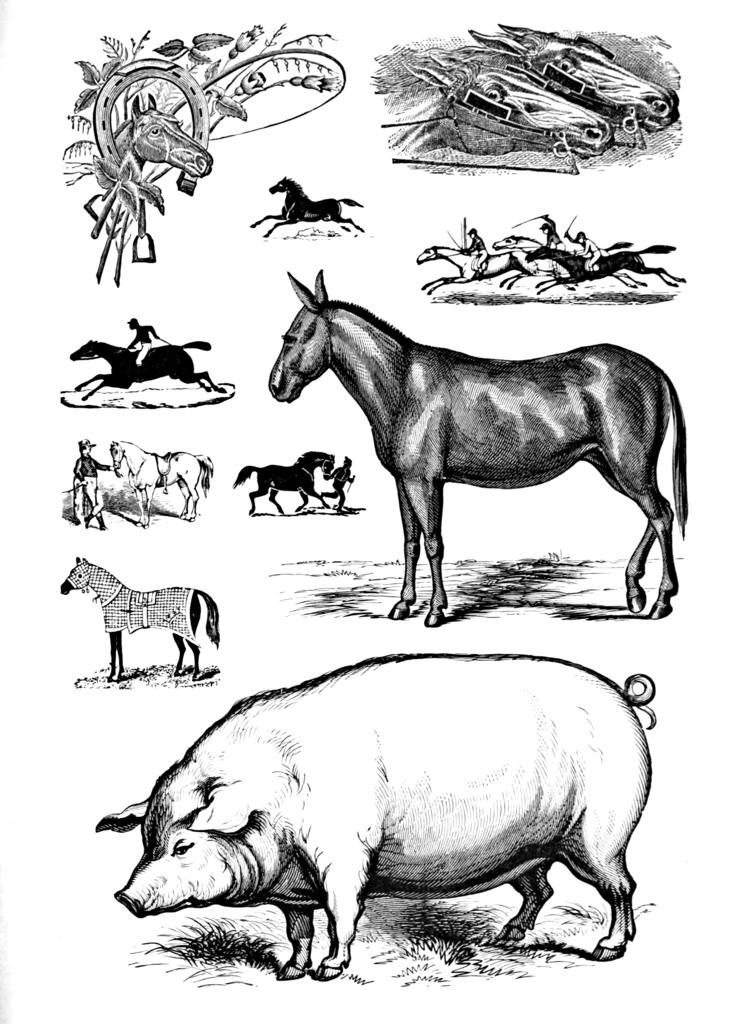What is the main subject in the foreground of the image? There is a sketch of animals in the foreground of the image. How many tickets are included in the sketch of animals in the image? There are no tickets present in the sketch of animals in the image. 